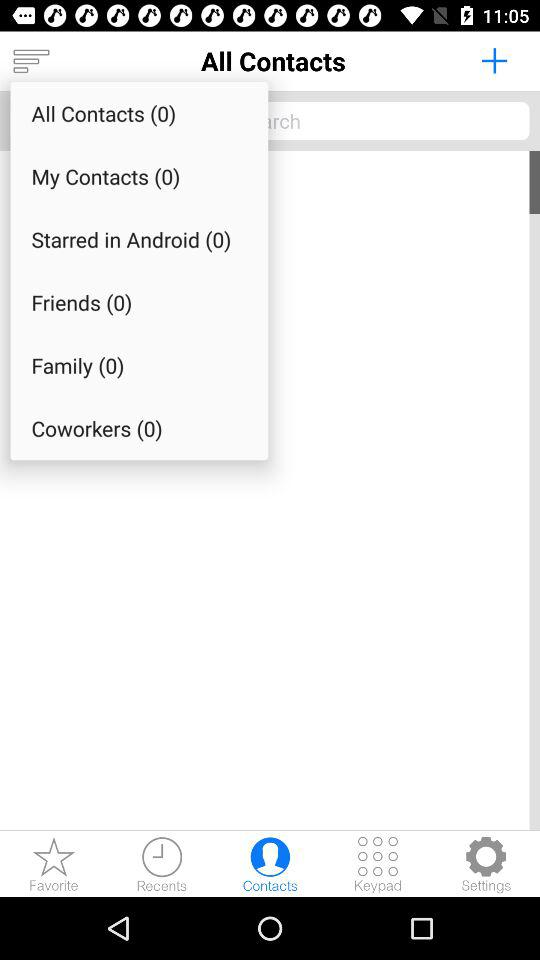What is the number of friends? The number of friends is 0. 